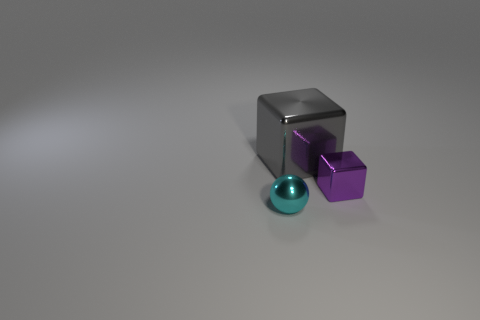The small shiny thing to the right of the object behind the tiny cube is what shape?
Offer a terse response. Cube. Is there anything else of the same color as the metal ball?
Give a very brief answer. No. Are there any gray cubes that are right of the block that is to the right of the metal cube that is on the left side of the small purple metallic cube?
Provide a succinct answer. No. There is a metal thing that is behind the tiny purple metallic cube; is its color the same as the shiny thing left of the large gray metal block?
Offer a terse response. No. What is the material of the sphere that is the same size as the purple metallic cube?
Ensure brevity in your answer.  Metal. What is the size of the metallic thing on the left side of the block behind the metallic thing on the right side of the large cube?
Your answer should be very brief. Small. What number of other things are made of the same material as the small purple thing?
Your answer should be compact. 2. What size is the metal thing behind the purple object?
Offer a very short reply. Large. How many metal objects are both in front of the large cube and behind the cyan object?
Offer a very short reply. 1. Is there a small purple matte cube?
Offer a very short reply. No. 